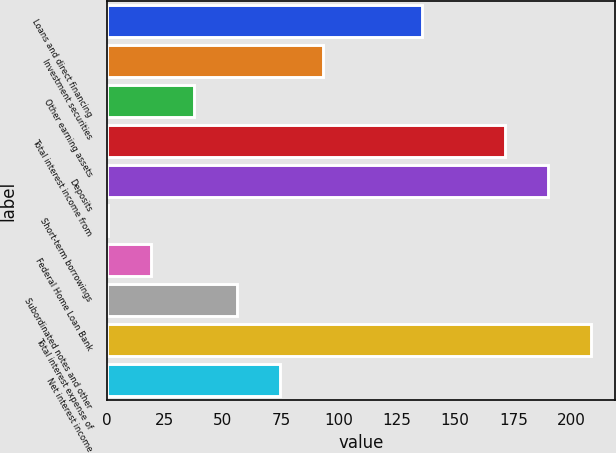Convert chart to OTSL. <chart><loc_0><loc_0><loc_500><loc_500><bar_chart><fcel>Loans and direct financing<fcel>Investment securities<fcel>Other earning assets<fcel>Total interest income from<fcel>Deposits<fcel>Short-term borrowings<fcel>Federal Home Loan Bank<fcel>Subordinated notes and other<fcel>Total interest expense of<fcel>Net interest income<nl><fcel>135.6<fcel>93.05<fcel>37.52<fcel>171.4<fcel>189.91<fcel>0.5<fcel>19.01<fcel>56.03<fcel>208.42<fcel>74.54<nl></chart> 